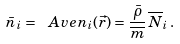<formula> <loc_0><loc_0><loc_500><loc_500>\bar { n } _ { i } = \ A v e { n _ { i } ( \vec { r } ) } = \frac { \bar { \rho } } { \overline { m } } \, \overline { N } _ { i } \, .</formula> 